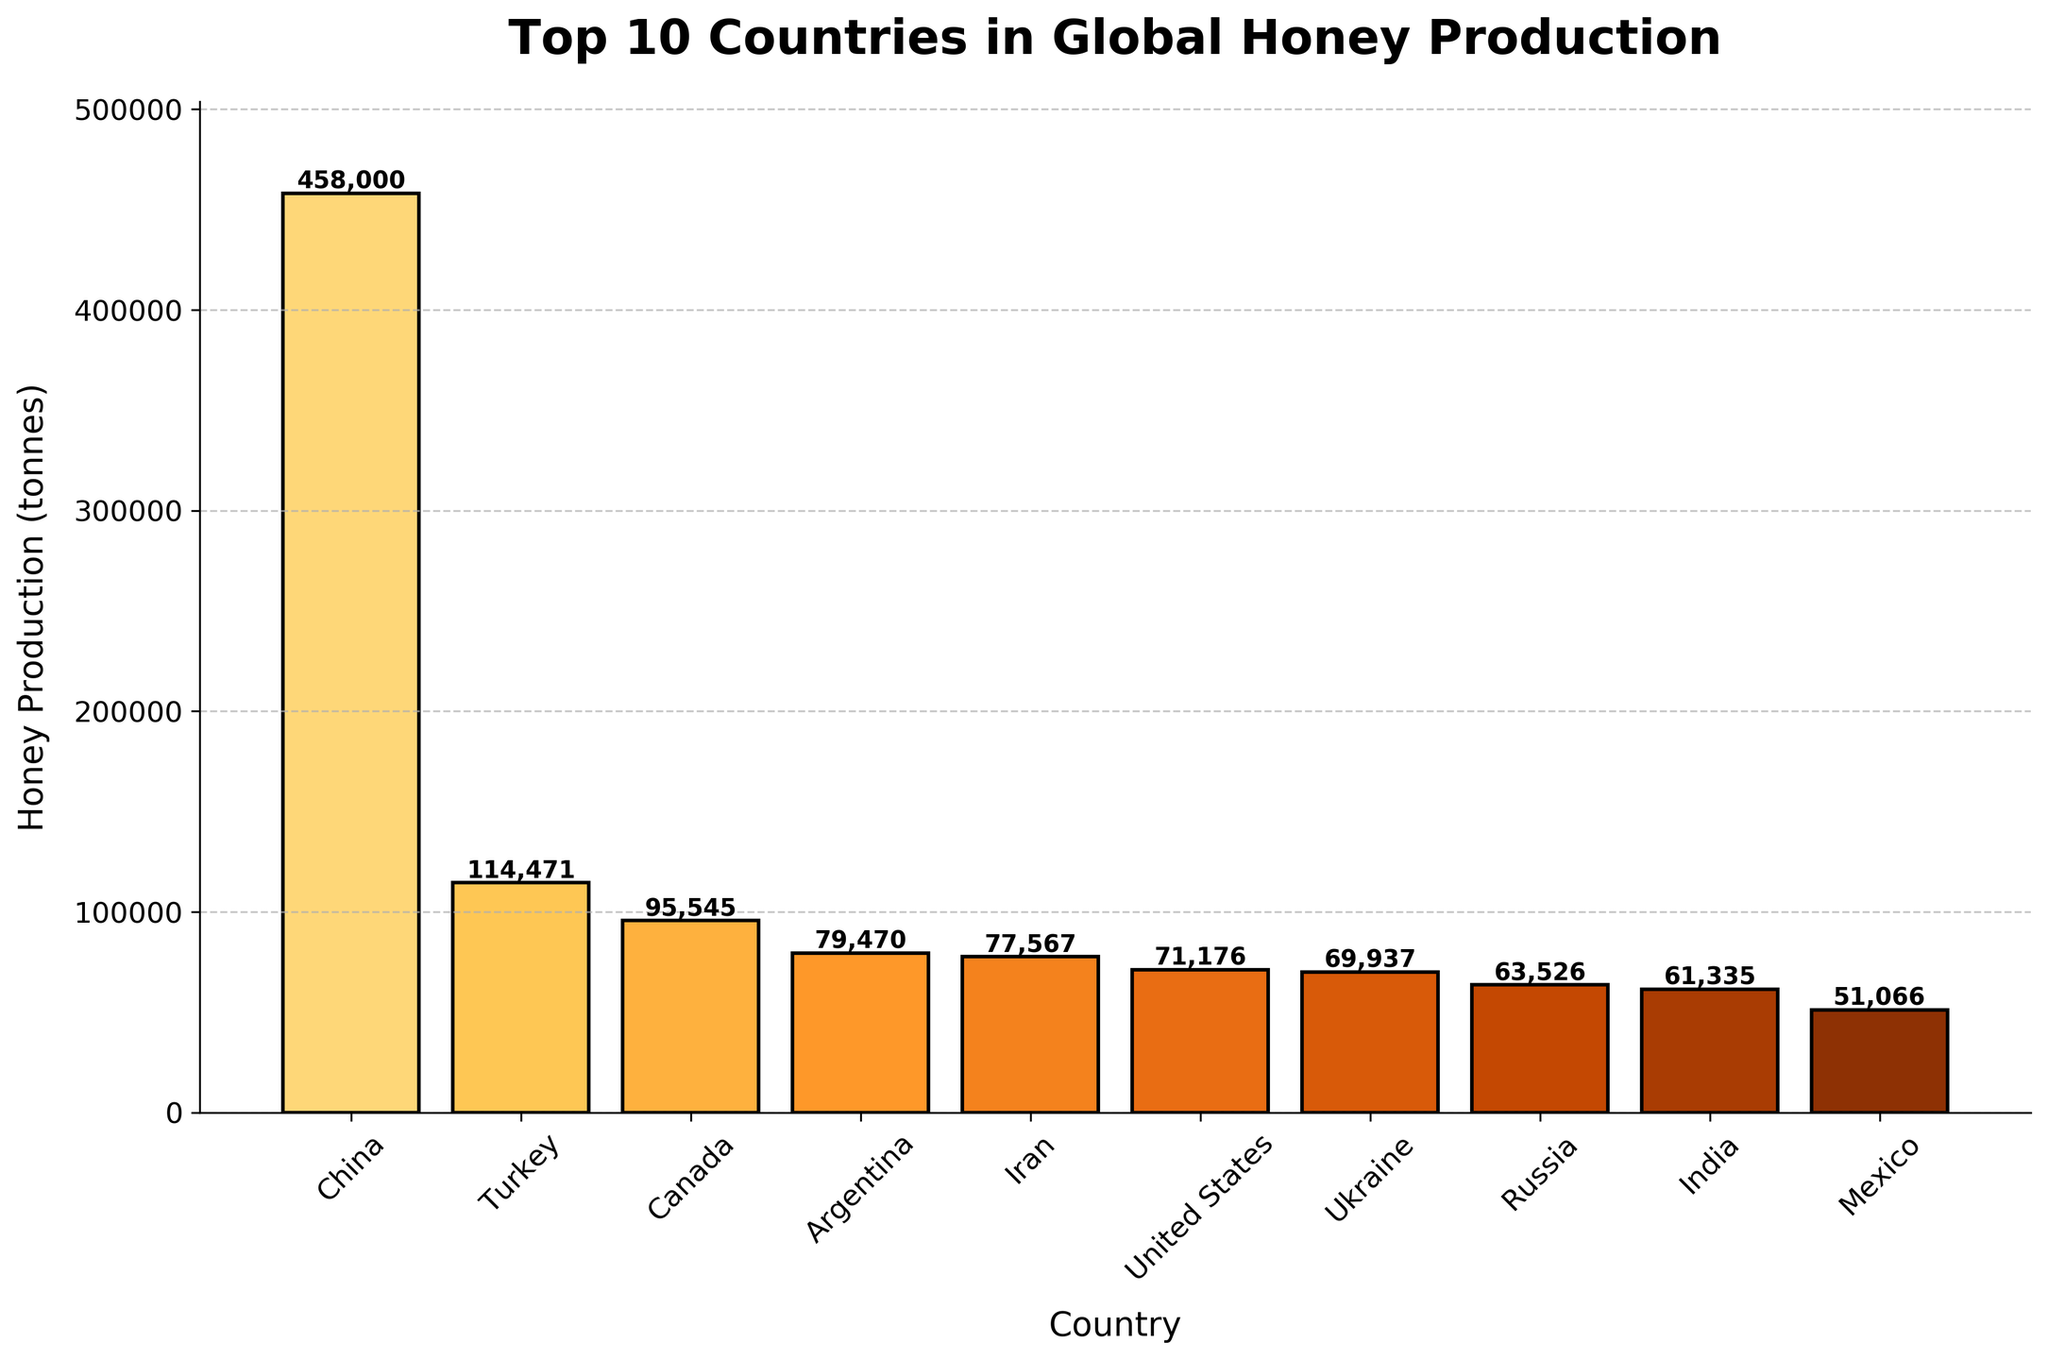Which country has the highest honey production? Looking at the bar chart, the tallest bar represents China.
Answer: China Which countries produce less honey than Turkey but more than the United States? By checking bars between Turkey and the United States, we find Canada, Argentina, and Iran.
Answer: Canada, Argentina, Iran What is the difference in honey production between China and Mexico? China's production is 458,000 tonnes, and Mexico's is 51,066 tonnes. The difference is 458,000 - 51,066.
Answer: 406,934 tonnes Which countries are producing more than 70,000 tonnes of honey? By examining the bars taller than 70,000 tonnes, we identify China, Turkey, Canada, Argentina, Iran, and the United States.
Answer: China, Turkey, Canada, Argentina, Iran, United States How much more honey does China produce compared to the total of the bottom three in the top 10? China produces 458,000 tonnes. The bottom three (Ukraine, Russia, India) produce 69,937 + 63,526 + 61,335 = 194,798 tonnes. The difference is 458,000 - 194,798.
Answer: 263,202 tonnes Which country has the smallest honey production among the top 10? The shortest bar in the top 10 represents Mexico.
Answer: Mexico What is the combined honey production of Turkey and Canada? Turkey produces 114,471 tonnes, and Canada produces 95,545 tonnes. Their combined production is 114,471 + 95,545.
Answer: 210,016 tonnes Is the honey production of Argentina closer to that of Canada or Iran? Argentina produces 79,470 tonnes, Canada produces 95,545 tonnes and Iran produces 77,567 tonnes. The differences are 95,545 - 79,470 = 16,075 and 79,470 - 77,567 = 1,903. Argentina is closer to Iran.
Answer: Iran What percentage of total top 10 honey production does China contribute? Total top 10 production is 458,000 + 114,471 + 95,545 + 79,470 + 77,567 + 71,176 + 69,937 + 63,526 + 61,335 + 51,066 = 1,142,093 tonnes. China's contribution percentage is (458,000 / 1,142,093) * 100 = 40.11%.
Answer: 40.11% Which country has approximately half the production of Indonesia? Since Indonesia is not in the provided list and we are looking within provided data, no comparison can be made.
Answer: None 